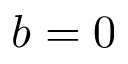<formula> <loc_0><loc_0><loc_500><loc_500>b = 0</formula> 